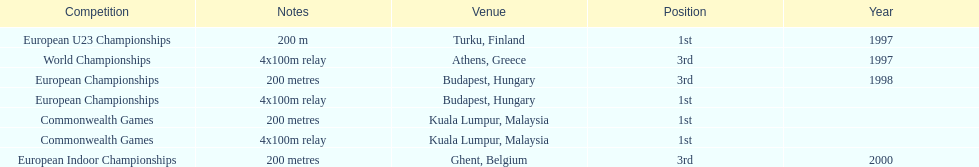Help me parse the entirety of this table. {'header': ['Competition', 'Notes', 'Venue', 'Position', 'Year'], 'rows': [['European U23 Championships', '200 m', 'Turku, Finland', '1st', '1997'], ['World Championships', '4x100m relay', 'Athens, Greece', '3rd', '1997'], ['European Championships', '200 metres', 'Budapest, Hungary', '3rd', '1998'], ['European Championships', '4x100m relay', 'Budapest, Hungary', '1st', ''], ['Commonwealth Games', '200 metres', 'Kuala Lumpur, Malaysia', '1st', ''], ['Commonwealth Games', '4x100m relay', 'Kuala Lumpur, Malaysia', '1st', ''], ['European Indoor Championships', '200 metres', 'Ghent, Belgium', '3rd', '2000']]} List the competitions that have the same relay as world championships from athens, greece. European Championships, Commonwealth Games. 